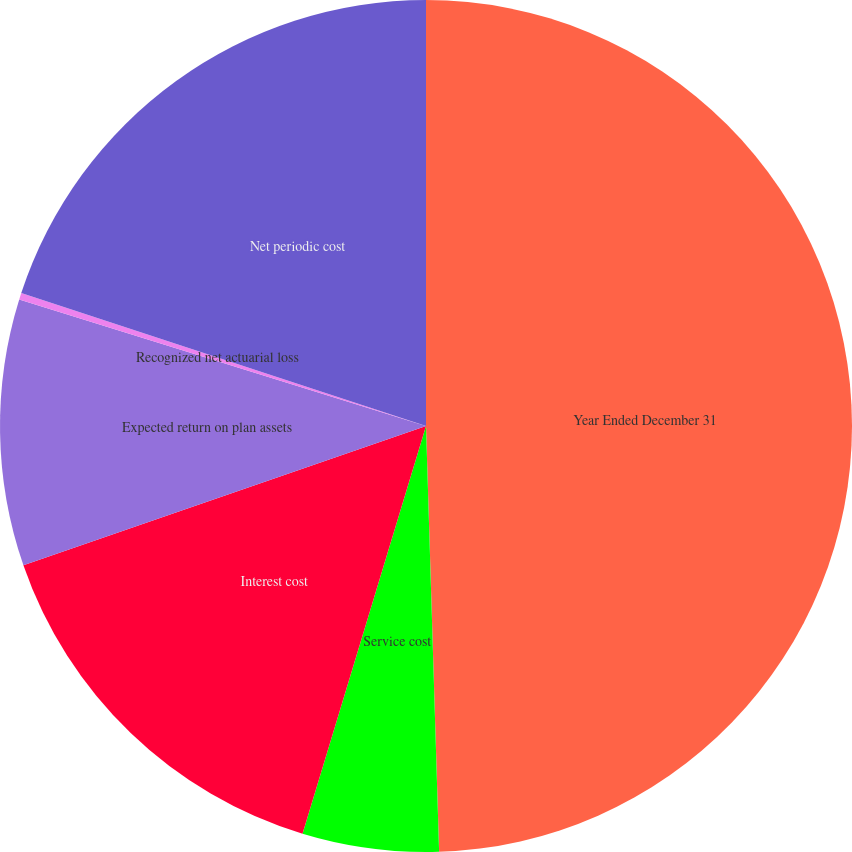Convert chart to OTSL. <chart><loc_0><loc_0><loc_500><loc_500><pie_chart><fcel>Year Ended December 31<fcel>Service cost<fcel>Interest cost<fcel>Expected return on plan assets<fcel>Recognized net actuarial loss<fcel>Net periodic cost<nl><fcel>49.51%<fcel>5.17%<fcel>15.02%<fcel>10.1%<fcel>0.25%<fcel>19.95%<nl></chart> 